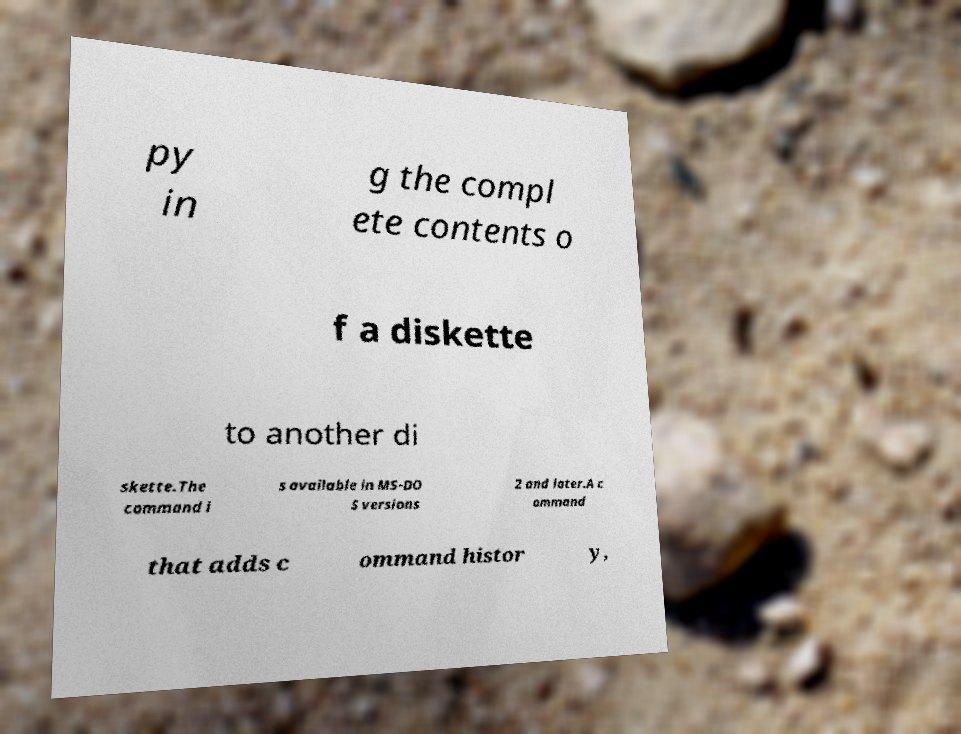Can you read and provide the text displayed in the image?This photo seems to have some interesting text. Can you extract and type it out for me? py in g the compl ete contents o f a diskette to another di skette.The command i s available in MS-DO S versions 2 and later.A c ommand that adds c ommand histor y, 